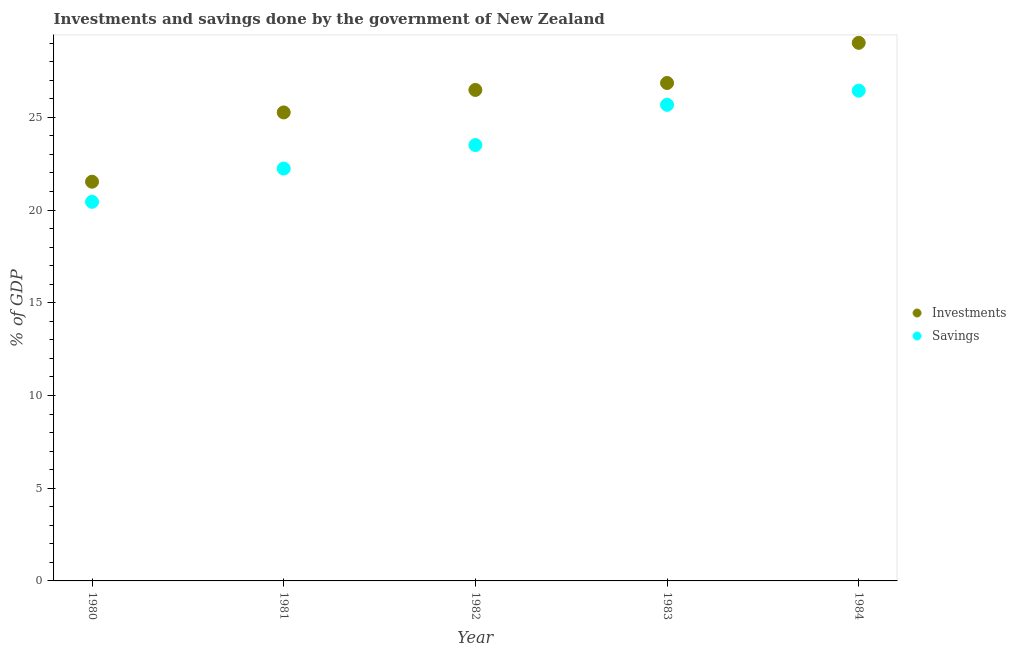Is the number of dotlines equal to the number of legend labels?
Keep it short and to the point. Yes. What is the savings of government in 1984?
Keep it short and to the point. 26.44. Across all years, what is the maximum savings of government?
Your answer should be very brief. 26.44. Across all years, what is the minimum investments of government?
Provide a short and direct response. 21.53. In which year was the investments of government maximum?
Keep it short and to the point. 1984. In which year was the investments of government minimum?
Offer a terse response. 1980. What is the total investments of government in the graph?
Offer a very short reply. 129.14. What is the difference between the savings of government in 1981 and that in 1982?
Offer a terse response. -1.27. What is the difference between the savings of government in 1982 and the investments of government in 1980?
Provide a succinct answer. 1.98. What is the average savings of government per year?
Your answer should be compact. 23.66. In the year 1983, what is the difference between the investments of government and savings of government?
Provide a succinct answer. 1.18. What is the ratio of the investments of government in 1980 to that in 1983?
Provide a short and direct response. 0.8. Is the investments of government in 1981 less than that in 1983?
Provide a short and direct response. Yes. What is the difference between the highest and the second highest investments of government?
Provide a short and direct response. 2.17. What is the difference between the highest and the lowest investments of government?
Provide a succinct answer. 7.49. In how many years, is the investments of government greater than the average investments of government taken over all years?
Offer a very short reply. 3. Is the sum of the investments of government in 1982 and 1983 greater than the maximum savings of government across all years?
Provide a succinct answer. Yes. Is the investments of government strictly greater than the savings of government over the years?
Your answer should be very brief. Yes. How many dotlines are there?
Your response must be concise. 2. What is the difference between two consecutive major ticks on the Y-axis?
Ensure brevity in your answer.  5. How many legend labels are there?
Your response must be concise. 2. What is the title of the graph?
Keep it short and to the point. Investments and savings done by the government of New Zealand. Does "Age 65(male)" appear as one of the legend labels in the graph?
Give a very brief answer. No. What is the label or title of the Y-axis?
Offer a very short reply. % of GDP. What is the % of GDP in Investments in 1980?
Provide a short and direct response. 21.53. What is the % of GDP of Savings in 1980?
Make the answer very short. 20.44. What is the % of GDP of Investments in 1981?
Make the answer very short. 25.26. What is the % of GDP of Savings in 1981?
Your answer should be very brief. 22.24. What is the % of GDP in Investments in 1982?
Ensure brevity in your answer.  26.48. What is the % of GDP in Savings in 1982?
Your answer should be compact. 23.51. What is the % of GDP in Investments in 1983?
Your answer should be compact. 26.85. What is the % of GDP in Savings in 1983?
Provide a succinct answer. 25.68. What is the % of GDP of Investments in 1984?
Provide a short and direct response. 29.02. What is the % of GDP in Savings in 1984?
Your answer should be compact. 26.44. Across all years, what is the maximum % of GDP of Investments?
Keep it short and to the point. 29.02. Across all years, what is the maximum % of GDP of Savings?
Provide a short and direct response. 26.44. Across all years, what is the minimum % of GDP in Investments?
Give a very brief answer. 21.53. Across all years, what is the minimum % of GDP in Savings?
Your response must be concise. 20.44. What is the total % of GDP of Investments in the graph?
Provide a succinct answer. 129.14. What is the total % of GDP of Savings in the graph?
Provide a succinct answer. 118.3. What is the difference between the % of GDP of Investments in 1980 and that in 1981?
Your answer should be compact. -3.74. What is the difference between the % of GDP of Savings in 1980 and that in 1981?
Offer a very short reply. -1.79. What is the difference between the % of GDP in Investments in 1980 and that in 1982?
Your response must be concise. -4.95. What is the difference between the % of GDP of Savings in 1980 and that in 1982?
Provide a short and direct response. -3.06. What is the difference between the % of GDP of Investments in 1980 and that in 1983?
Provide a succinct answer. -5.32. What is the difference between the % of GDP in Savings in 1980 and that in 1983?
Ensure brevity in your answer.  -5.23. What is the difference between the % of GDP of Investments in 1980 and that in 1984?
Your response must be concise. -7.49. What is the difference between the % of GDP in Savings in 1980 and that in 1984?
Ensure brevity in your answer.  -5.99. What is the difference between the % of GDP of Investments in 1981 and that in 1982?
Provide a short and direct response. -1.21. What is the difference between the % of GDP of Savings in 1981 and that in 1982?
Provide a succinct answer. -1.27. What is the difference between the % of GDP of Investments in 1981 and that in 1983?
Provide a succinct answer. -1.59. What is the difference between the % of GDP in Savings in 1981 and that in 1983?
Your response must be concise. -3.44. What is the difference between the % of GDP in Investments in 1981 and that in 1984?
Your answer should be very brief. -3.75. What is the difference between the % of GDP in Savings in 1981 and that in 1984?
Offer a terse response. -4.2. What is the difference between the % of GDP in Investments in 1982 and that in 1983?
Your response must be concise. -0.37. What is the difference between the % of GDP of Savings in 1982 and that in 1983?
Ensure brevity in your answer.  -2.17. What is the difference between the % of GDP in Investments in 1982 and that in 1984?
Provide a short and direct response. -2.54. What is the difference between the % of GDP in Savings in 1982 and that in 1984?
Give a very brief answer. -2.93. What is the difference between the % of GDP of Investments in 1983 and that in 1984?
Offer a terse response. -2.17. What is the difference between the % of GDP of Savings in 1983 and that in 1984?
Ensure brevity in your answer.  -0.76. What is the difference between the % of GDP in Investments in 1980 and the % of GDP in Savings in 1981?
Provide a short and direct response. -0.71. What is the difference between the % of GDP in Investments in 1980 and the % of GDP in Savings in 1982?
Make the answer very short. -1.98. What is the difference between the % of GDP of Investments in 1980 and the % of GDP of Savings in 1983?
Offer a terse response. -4.15. What is the difference between the % of GDP of Investments in 1980 and the % of GDP of Savings in 1984?
Your answer should be compact. -4.91. What is the difference between the % of GDP in Investments in 1981 and the % of GDP in Savings in 1982?
Your answer should be compact. 1.76. What is the difference between the % of GDP in Investments in 1981 and the % of GDP in Savings in 1983?
Your answer should be compact. -0.41. What is the difference between the % of GDP of Investments in 1981 and the % of GDP of Savings in 1984?
Your response must be concise. -1.17. What is the difference between the % of GDP of Investments in 1982 and the % of GDP of Savings in 1983?
Your response must be concise. 0.8. What is the difference between the % of GDP in Investments in 1982 and the % of GDP in Savings in 1984?
Keep it short and to the point. 0.04. What is the difference between the % of GDP of Investments in 1983 and the % of GDP of Savings in 1984?
Offer a very short reply. 0.41. What is the average % of GDP of Investments per year?
Ensure brevity in your answer.  25.83. What is the average % of GDP of Savings per year?
Make the answer very short. 23.66. In the year 1980, what is the difference between the % of GDP in Investments and % of GDP in Savings?
Provide a succinct answer. 1.08. In the year 1981, what is the difference between the % of GDP of Investments and % of GDP of Savings?
Give a very brief answer. 3.03. In the year 1982, what is the difference between the % of GDP in Investments and % of GDP in Savings?
Provide a succinct answer. 2.97. In the year 1983, what is the difference between the % of GDP in Investments and % of GDP in Savings?
Your answer should be compact. 1.18. In the year 1984, what is the difference between the % of GDP in Investments and % of GDP in Savings?
Your answer should be very brief. 2.58. What is the ratio of the % of GDP in Investments in 1980 to that in 1981?
Provide a short and direct response. 0.85. What is the ratio of the % of GDP of Savings in 1980 to that in 1981?
Make the answer very short. 0.92. What is the ratio of the % of GDP in Investments in 1980 to that in 1982?
Keep it short and to the point. 0.81. What is the ratio of the % of GDP in Savings in 1980 to that in 1982?
Make the answer very short. 0.87. What is the ratio of the % of GDP in Investments in 1980 to that in 1983?
Your answer should be very brief. 0.8. What is the ratio of the % of GDP of Savings in 1980 to that in 1983?
Your answer should be very brief. 0.8. What is the ratio of the % of GDP in Investments in 1980 to that in 1984?
Provide a short and direct response. 0.74. What is the ratio of the % of GDP in Savings in 1980 to that in 1984?
Keep it short and to the point. 0.77. What is the ratio of the % of GDP in Investments in 1981 to that in 1982?
Your answer should be very brief. 0.95. What is the ratio of the % of GDP of Savings in 1981 to that in 1982?
Give a very brief answer. 0.95. What is the ratio of the % of GDP of Investments in 1981 to that in 1983?
Your answer should be very brief. 0.94. What is the ratio of the % of GDP of Savings in 1981 to that in 1983?
Your answer should be compact. 0.87. What is the ratio of the % of GDP in Investments in 1981 to that in 1984?
Make the answer very short. 0.87. What is the ratio of the % of GDP of Savings in 1981 to that in 1984?
Make the answer very short. 0.84. What is the ratio of the % of GDP of Investments in 1982 to that in 1983?
Provide a short and direct response. 0.99. What is the ratio of the % of GDP in Savings in 1982 to that in 1983?
Make the answer very short. 0.92. What is the ratio of the % of GDP in Investments in 1982 to that in 1984?
Give a very brief answer. 0.91. What is the ratio of the % of GDP of Savings in 1982 to that in 1984?
Your answer should be very brief. 0.89. What is the ratio of the % of GDP in Investments in 1983 to that in 1984?
Give a very brief answer. 0.93. What is the ratio of the % of GDP in Savings in 1983 to that in 1984?
Your answer should be very brief. 0.97. What is the difference between the highest and the second highest % of GDP of Investments?
Ensure brevity in your answer.  2.17. What is the difference between the highest and the second highest % of GDP in Savings?
Offer a very short reply. 0.76. What is the difference between the highest and the lowest % of GDP in Investments?
Provide a short and direct response. 7.49. What is the difference between the highest and the lowest % of GDP in Savings?
Offer a very short reply. 5.99. 